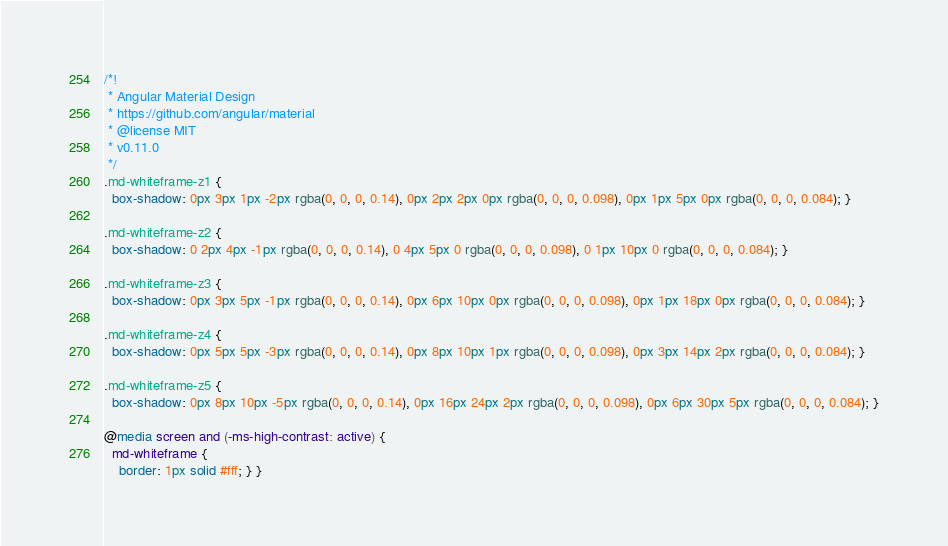Convert code to text. <code><loc_0><loc_0><loc_500><loc_500><_CSS_>/*!
 * Angular Material Design
 * https://github.com/angular/material
 * @license MIT
 * v0.11.0
 */
.md-whiteframe-z1 {
  box-shadow: 0px 3px 1px -2px rgba(0, 0, 0, 0.14), 0px 2px 2px 0px rgba(0, 0, 0, 0.098), 0px 1px 5px 0px rgba(0, 0, 0, 0.084); }

.md-whiteframe-z2 {
  box-shadow: 0 2px 4px -1px rgba(0, 0, 0, 0.14), 0 4px 5px 0 rgba(0, 0, 0, 0.098), 0 1px 10px 0 rgba(0, 0, 0, 0.084); }

.md-whiteframe-z3 {
  box-shadow: 0px 3px 5px -1px rgba(0, 0, 0, 0.14), 0px 6px 10px 0px rgba(0, 0, 0, 0.098), 0px 1px 18px 0px rgba(0, 0, 0, 0.084); }

.md-whiteframe-z4 {
  box-shadow: 0px 5px 5px -3px rgba(0, 0, 0, 0.14), 0px 8px 10px 1px rgba(0, 0, 0, 0.098), 0px 3px 14px 2px rgba(0, 0, 0, 0.084); }

.md-whiteframe-z5 {
  box-shadow: 0px 8px 10px -5px rgba(0, 0, 0, 0.14), 0px 16px 24px 2px rgba(0, 0, 0, 0.098), 0px 6px 30px 5px rgba(0, 0, 0, 0.084); }

@media screen and (-ms-high-contrast: active) {
  md-whiteframe {
    border: 1px solid #fff; } }
</code> 